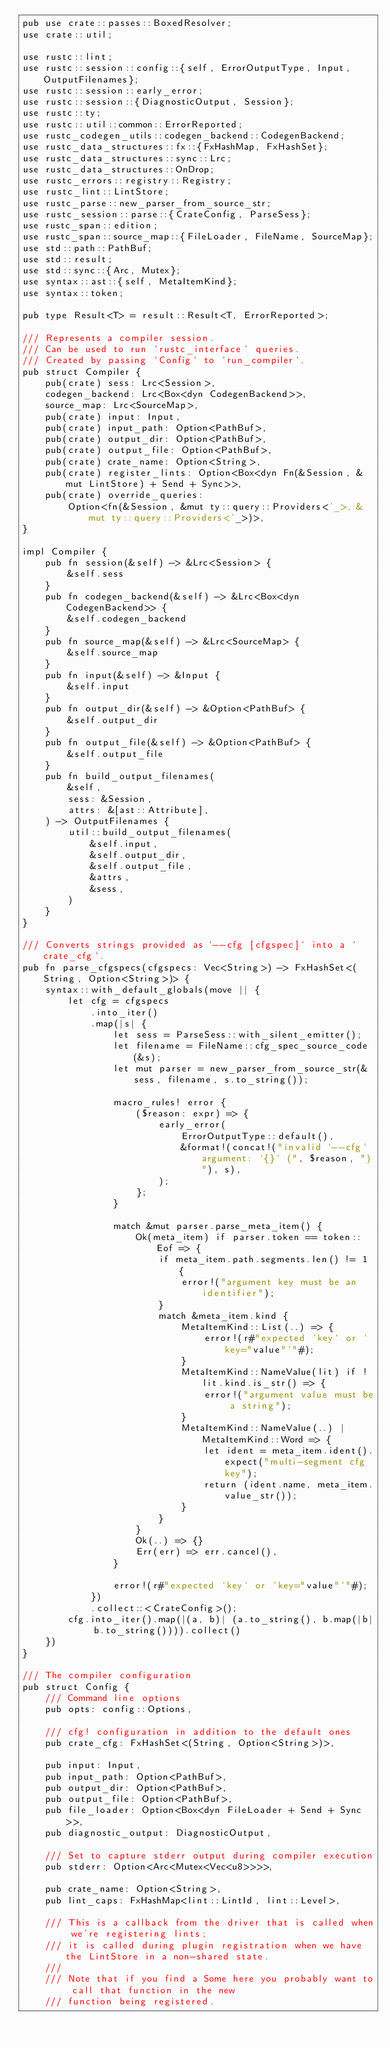<code> <loc_0><loc_0><loc_500><loc_500><_Rust_>pub use crate::passes::BoxedResolver;
use crate::util;

use rustc::lint;
use rustc::session::config::{self, ErrorOutputType, Input, OutputFilenames};
use rustc::session::early_error;
use rustc::session::{DiagnosticOutput, Session};
use rustc::ty;
use rustc::util::common::ErrorReported;
use rustc_codegen_utils::codegen_backend::CodegenBackend;
use rustc_data_structures::fx::{FxHashMap, FxHashSet};
use rustc_data_structures::sync::Lrc;
use rustc_data_structures::OnDrop;
use rustc_errors::registry::Registry;
use rustc_lint::LintStore;
use rustc_parse::new_parser_from_source_str;
use rustc_session::parse::{CrateConfig, ParseSess};
use rustc_span::edition;
use rustc_span::source_map::{FileLoader, FileName, SourceMap};
use std::path::PathBuf;
use std::result;
use std::sync::{Arc, Mutex};
use syntax::ast::{self, MetaItemKind};
use syntax::token;

pub type Result<T> = result::Result<T, ErrorReported>;

/// Represents a compiler session.
/// Can be used to run `rustc_interface` queries.
/// Created by passing `Config` to `run_compiler`.
pub struct Compiler {
    pub(crate) sess: Lrc<Session>,
    codegen_backend: Lrc<Box<dyn CodegenBackend>>,
    source_map: Lrc<SourceMap>,
    pub(crate) input: Input,
    pub(crate) input_path: Option<PathBuf>,
    pub(crate) output_dir: Option<PathBuf>,
    pub(crate) output_file: Option<PathBuf>,
    pub(crate) crate_name: Option<String>,
    pub(crate) register_lints: Option<Box<dyn Fn(&Session, &mut LintStore) + Send + Sync>>,
    pub(crate) override_queries:
        Option<fn(&Session, &mut ty::query::Providers<'_>, &mut ty::query::Providers<'_>)>,
}

impl Compiler {
    pub fn session(&self) -> &Lrc<Session> {
        &self.sess
    }
    pub fn codegen_backend(&self) -> &Lrc<Box<dyn CodegenBackend>> {
        &self.codegen_backend
    }
    pub fn source_map(&self) -> &Lrc<SourceMap> {
        &self.source_map
    }
    pub fn input(&self) -> &Input {
        &self.input
    }
    pub fn output_dir(&self) -> &Option<PathBuf> {
        &self.output_dir
    }
    pub fn output_file(&self) -> &Option<PathBuf> {
        &self.output_file
    }
    pub fn build_output_filenames(
        &self,
        sess: &Session,
        attrs: &[ast::Attribute],
    ) -> OutputFilenames {
        util::build_output_filenames(
            &self.input,
            &self.output_dir,
            &self.output_file,
            &attrs,
            &sess,
        )
    }
}

/// Converts strings provided as `--cfg [cfgspec]` into a `crate_cfg`.
pub fn parse_cfgspecs(cfgspecs: Vec<String>) -> FxHashSet<(String, Option<String>)> {
    syntax::with_default_globals(move || {
        let cfg = cfgspecs
            .into_iter()
            .map(|s| {
                let sess = ParseSess::with_silent_emitter();
                let filename = FileName::cfg_spec_source_code(&s);
                let mut parser = new_parser_from_source_str(&sess, filename, s.to_string());

                macro_rules! error {
                    ($reason: expr) => {
                        early_error(
                            ErrorOutputType::default(),
                            &format!(concat!("invalid `--cfg` argument: `{}` (", $reason, ")"), s),
                        );
                    };
                }

                match &mut parser.parse_meta_item() {
                    Ok(meta_item) if parser.token == token::Eof => {
                        if meta_item.path.segments.len() != 1 {
                            error!("argument key must be an identifier");
                        }
                        match &meta_item.kind {
                            MetaItemKind::List(..) => {
                                error!(r#"expected `key` or `key="value"`"#);
                            }
                            MetaItemKind::NameValue(lit) if !lit.kind.is_str() => {
                                error!("argument value must be a string");
                            }
                            MetaItemKind::NameValue(..) | MetaItemKind::Word => {
                                let ident = meta_item.ident().expect("multi-segment cfg key");
                                return (ident.name, meta_item.value_str());
                            }
                        }
                    }
                    Ok(..) => {}
                    Err(err) => err.cancel(),
                }

                error!(r#"expected `key` or `key="value"`"#);
            })
            .collect::<CrateConfig>();
        cfg.into_iter().map(|(a, b)| (a.to_string(), b.map(|b| b.to_string()))).collect()
    })
}

/// The compiler configuration
pub struct Config {
    /// Command line options
    pub opts: config::Options,

    /// cfg! configuration in addition to the default ones
    pub crate_cfg: FxHashSet<(String, Option<String>)>,

    pub input: Input,
    pub input_path: Option<PathBuf>,
    pub output_dir: Option<PathBuf>,
    pub output_file: Option<PathBuf>,
    pub file_loader: Option<Box<dyn FileLoader + Send + Sync>>,
    pub diagnostic_output: DiagnosticOutput,

    /// Set to capture stderr output during compiler execution
    pub stderr: Option<Arc<Mutex<Vec<u8>>>>,

    pub crate_name: Option<String>,
    pub lint_caps: FxHashMap<lint::LintId, lint::Level>,

    /// This is a callback from the driver that is called when we're registering lints;
    /// it is called during plugin registration when we have the LintStore in a non-shared state.
    ///
    /// Note that if you find a Some here you probably want to call that function in the new
    /// function being registered.</code> 